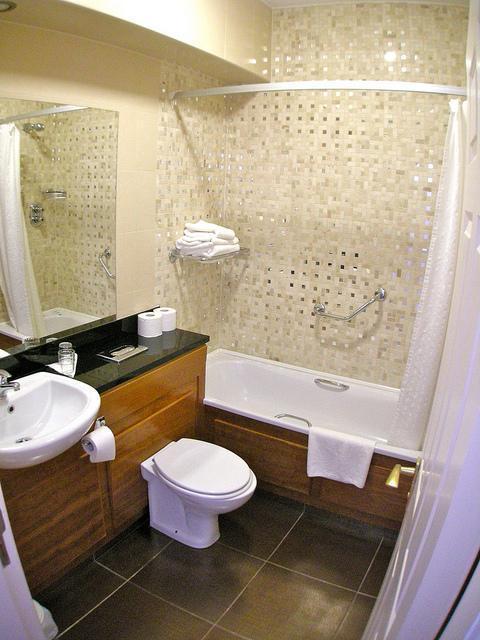How many rolls of toilet paper are next to the sink?
Give a very brief answer. 2. 